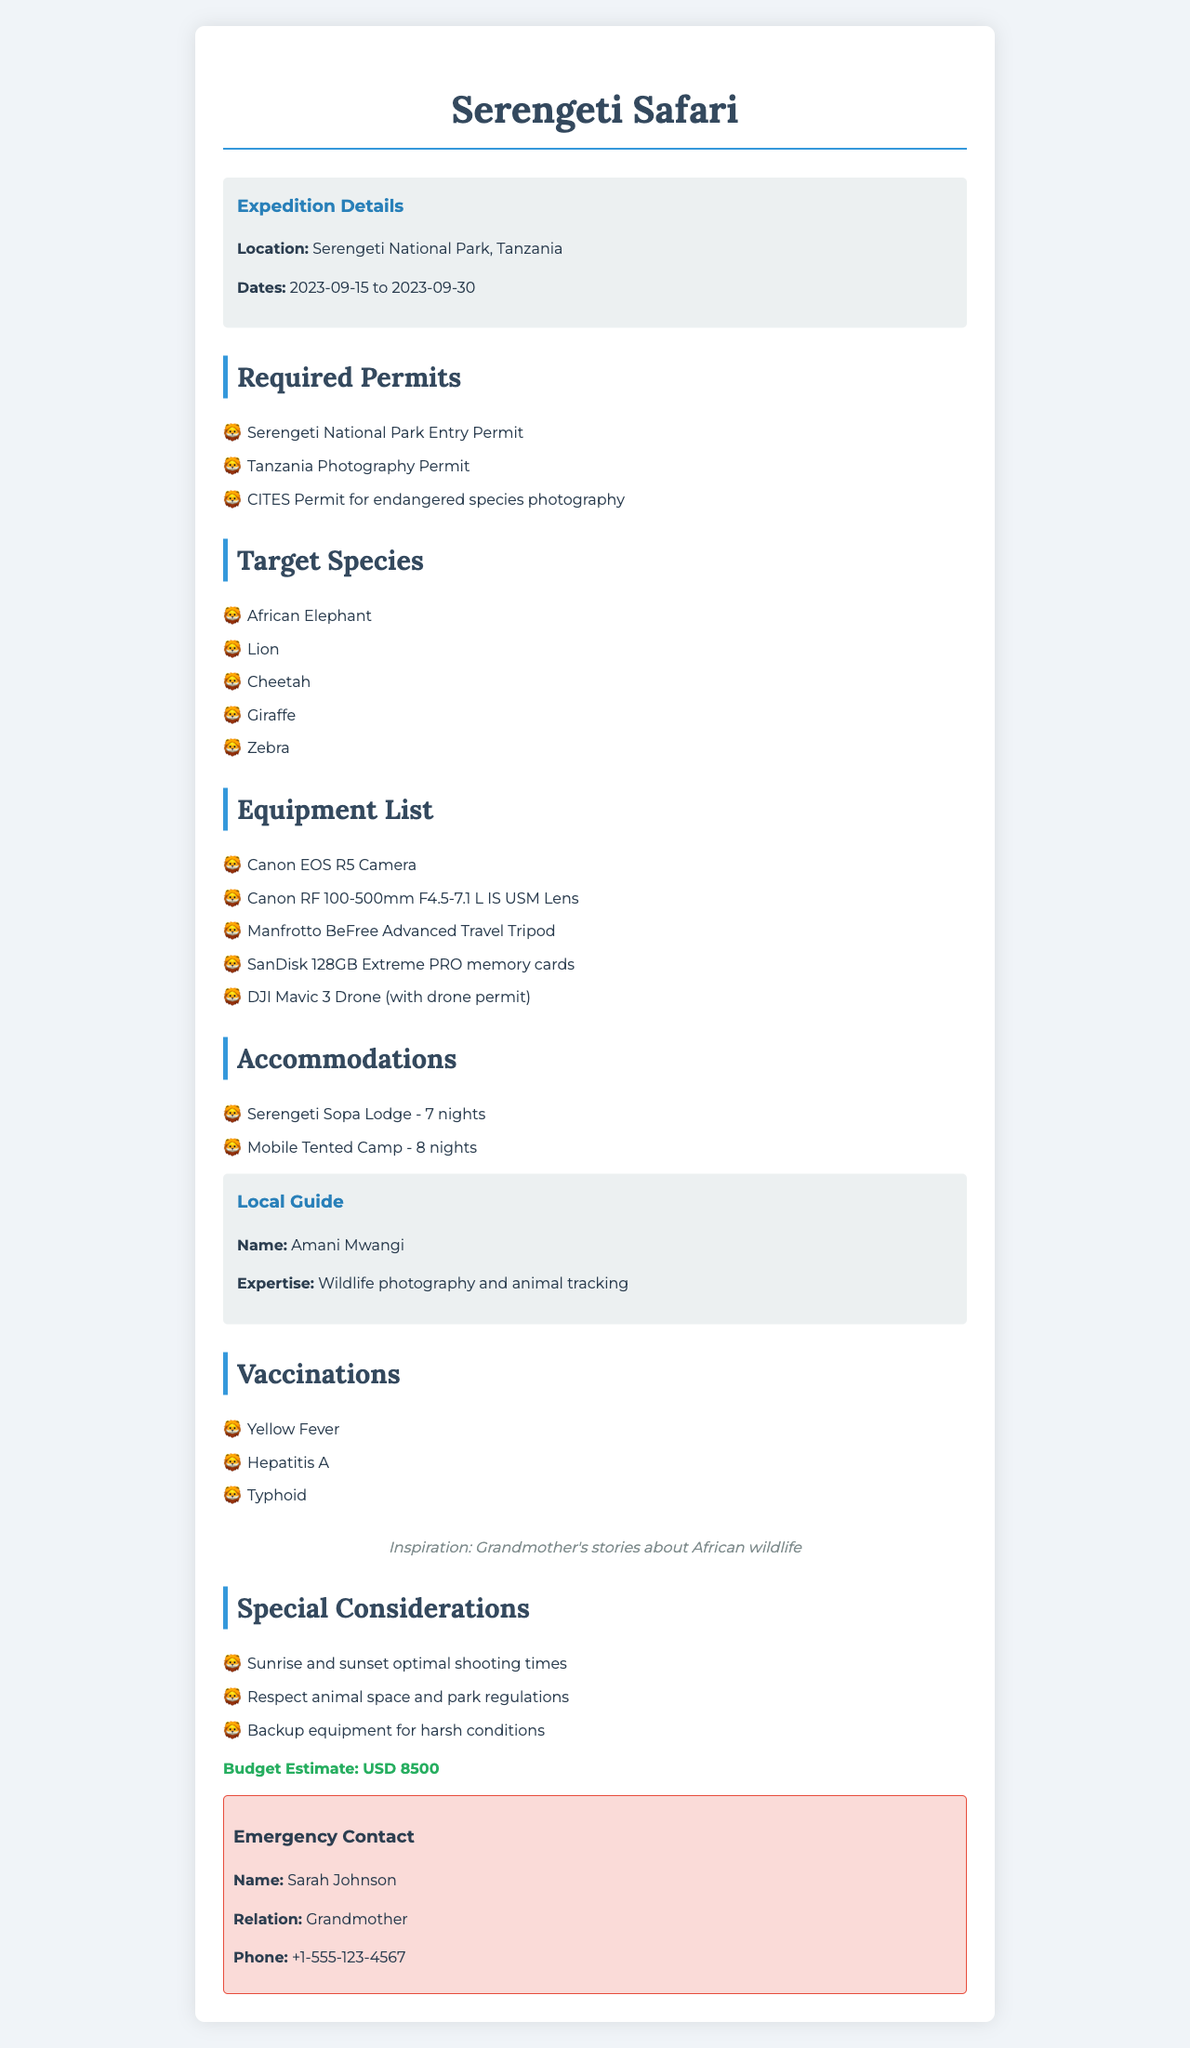What is the location of the expedition? The location is specified in the document and is "Serengeti National Park, Tanzania."
Answer: Serengeti National Park, Tanzania What are the start and end dates of the expedition? The dates are clearly mentioned, starting from "2023-09-15" to "2023-09-30."
Answer: 2023-09-15 to 2023-09-30 How many nights will be spent at the Mobile Tented Camp? The number of nights is listed under accommodations for the Mobile Tented Camp, which is 8 nights.
Answer: 8 nights List one required permit for the expedition. The document lists multiple permits; one is the "Tanzania Photography Permit."
Answer: Tanzania Photography Permit Who is the local guide, and what is their expertise? The name and expertise are provided; the guide is "Amani Mwangi" with expertise in "Wildlife photography and animal tracking."
Answer: Amani Mwangi; Wildlife photography and animal tracking How much is the budget estimate for the expedition? The budget amount is stated as "8500" in USD.
Answer: 8500 What is the inspiration source mentioned in the document? The inspiration source is specifically mentioned as "Grandmother's stories about African wildlife."
Answer: Grandmother's stories about African wildlife What special consideration should be kept in mind during shooting? One of the special considerations is to "Respect animal space and park regulations."
Answer: Respect animal space and park regulations What is the total number of target species listed? The document lists 5 target species for the expedition.
Answer: 5 